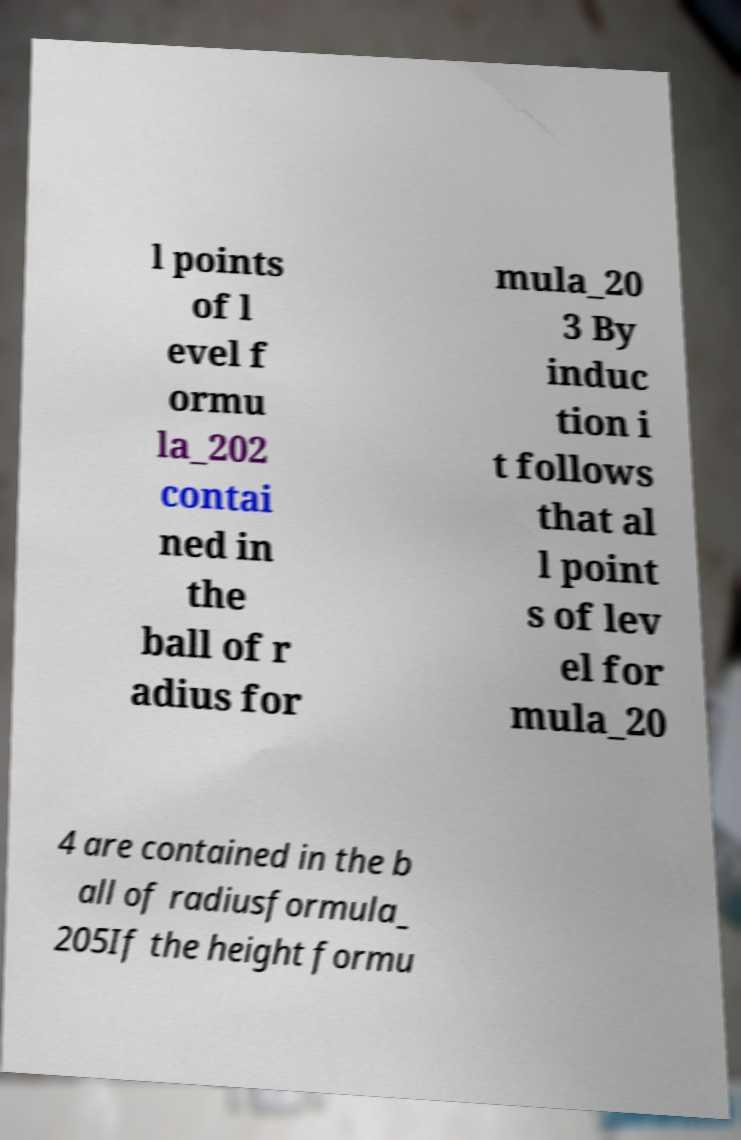Can you read and provide the text displayed in the image?This photo seems to have some interesting text. Can you extract and type it out for me? l points of l evel f ormu la_202 contai ned in the ball of r adius for mula_20 3 By induc tion i t follows that al l point s of lev el for mula_20 4 are contained in the b all of radiusformula_ 205If the height formu 